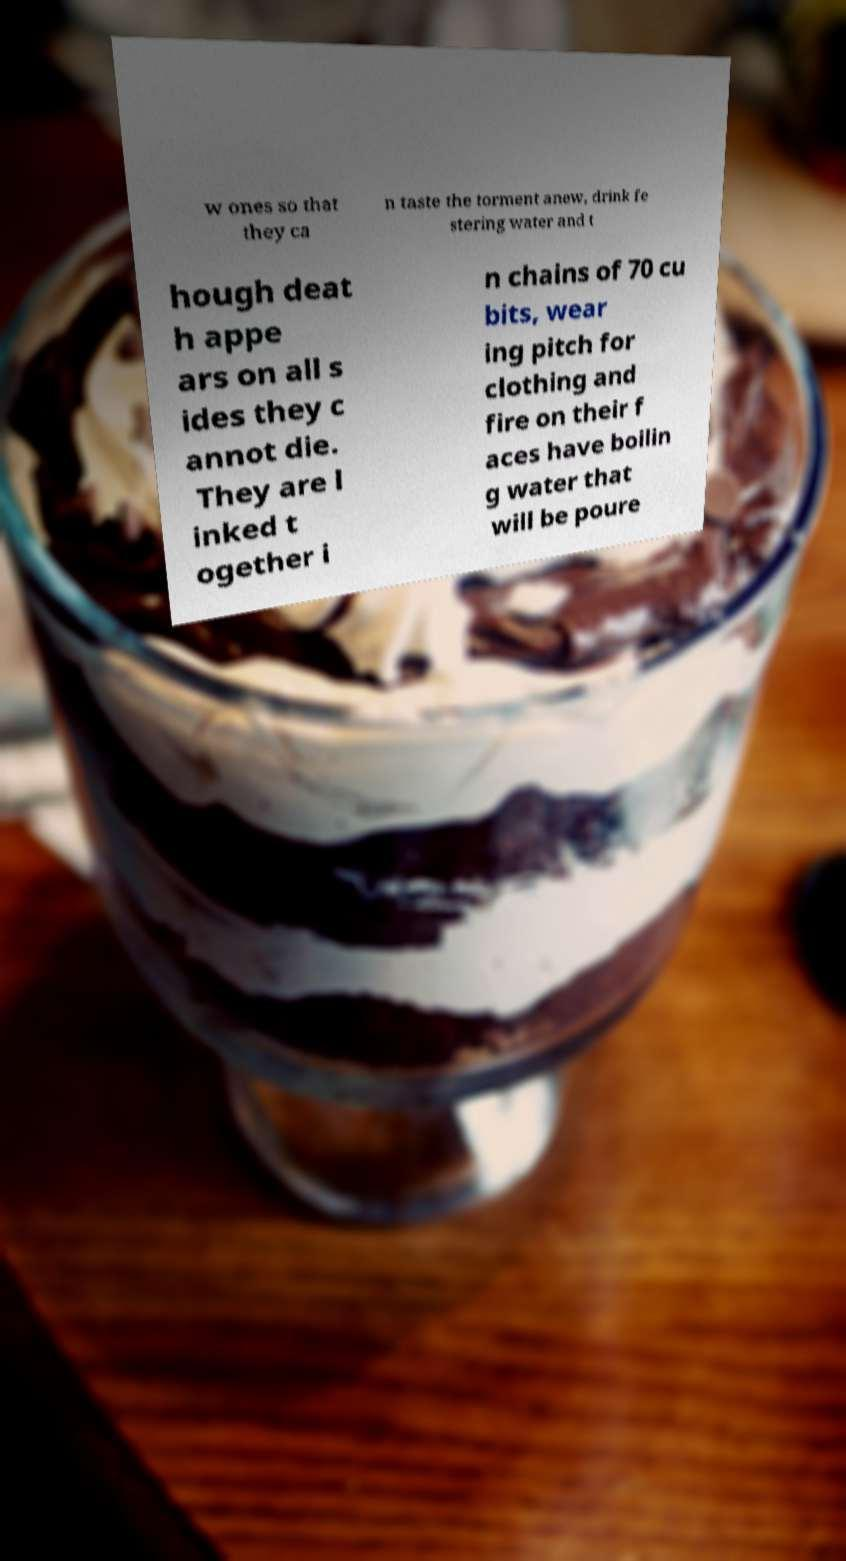There's text embedded in this image that I need extracted. Can you transcribe it verbatim? w ones so that they ca n taste the torment anew, drink fe stering water and t hough deat h appe ars on all s ides they c annot die. They are l inked t ogether i n chains of 70 cu bits, wear ing pitch for clothing and fire on their f aces have boilin g water that will be poure 